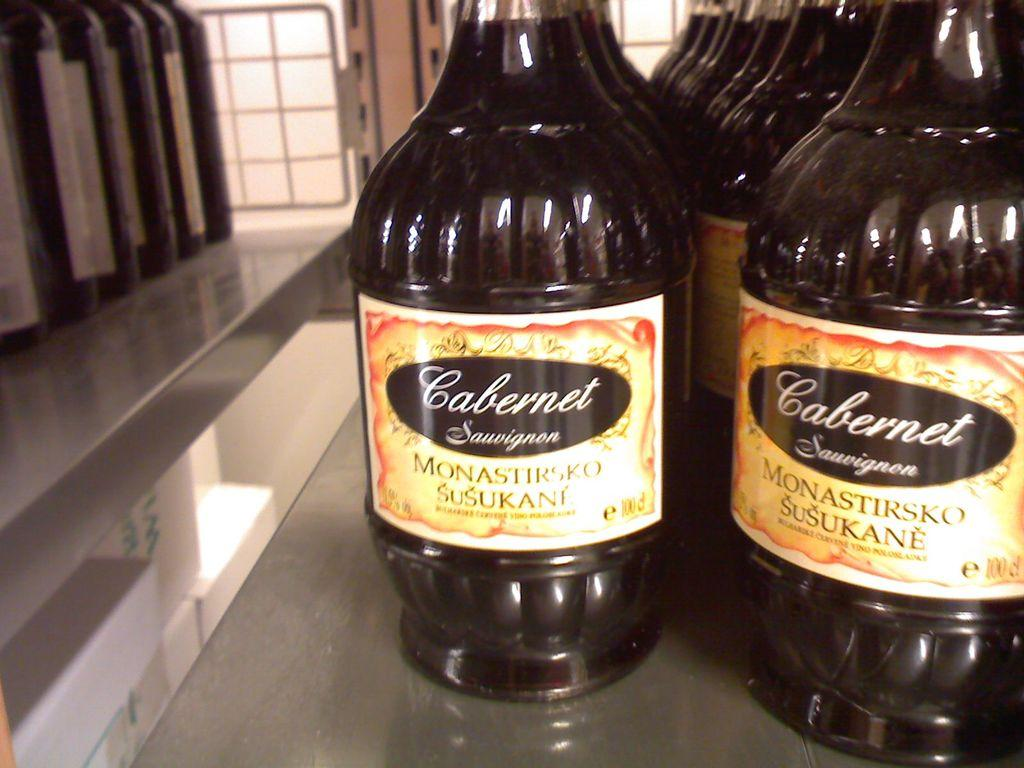<image>
Offer a succinct explanation of the picture presented. bottles of Cabernet Sauvingnon lined up on a table 